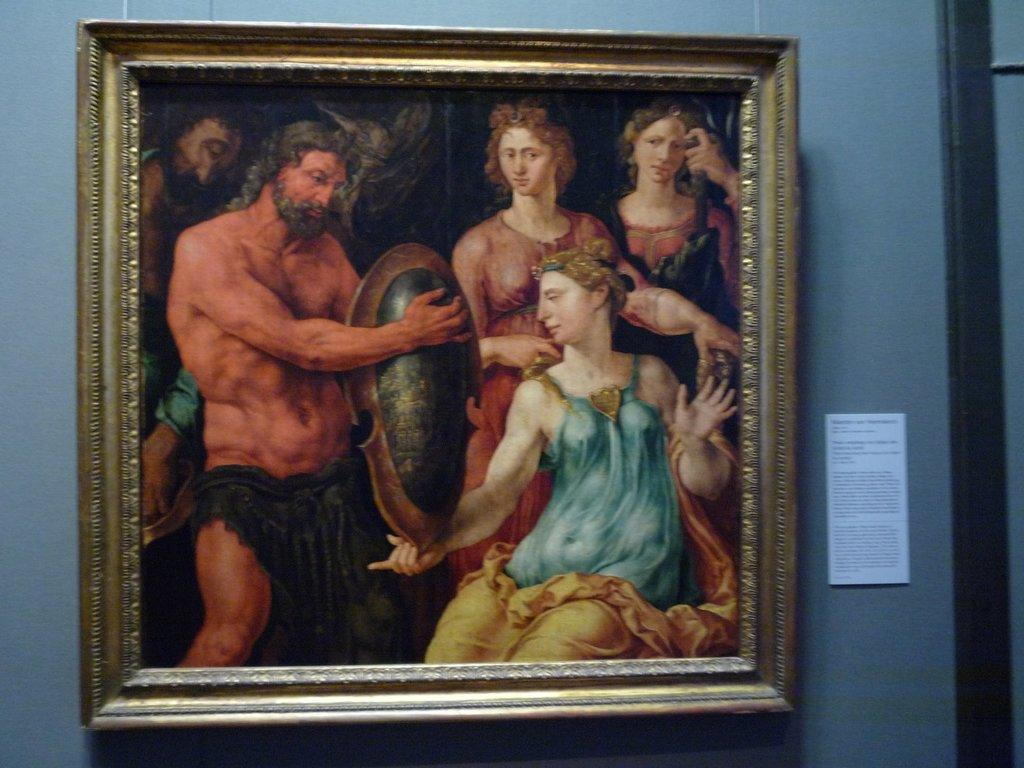What can be seen hanging on the wall in the image? There is a photo frame on the wall in the image. What type of decoration or label is present in the image? There is a sticker in the image. What color and location can be identified for an object in the image? There is a black color object on the right side of the image. Can you tell me how many slices of bread are on the floor in the image? There is no bread present in the image. What type of animal can be seen playing with a skate in the image? There is no animal or skate present in the image. 